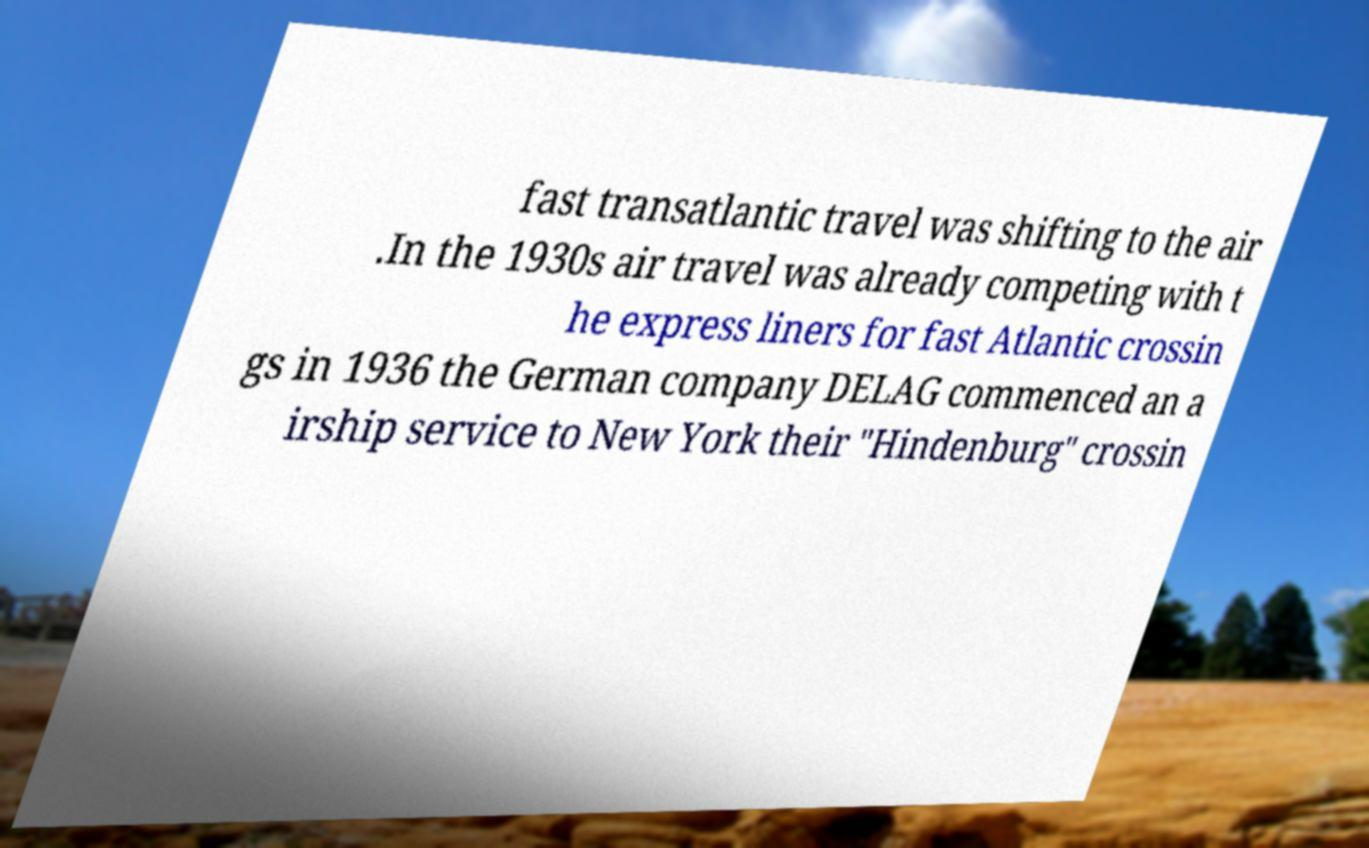For documentation purposes, I need the text within this image transcribed. Could you provide that? fast transatlantic travel was shifting to the air .In the 1930s air travel was already competing with t he express liners for fast Atlantic crossin gs in 1936 the German company DELAG commenced an a irship service to New York their "Hindenburg" crossin 